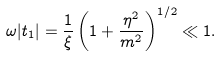<formula> <loc_0><loc_0><loc_500><loc_500>\omega | t _ { 1 } | = \frac { 1 } { \xi } \left ( 1 + \frac { \eta ^ { 2 } } { m ^ { 2 } } \right ) ^ { 1 / 2 } \ll 1 .</formula> 